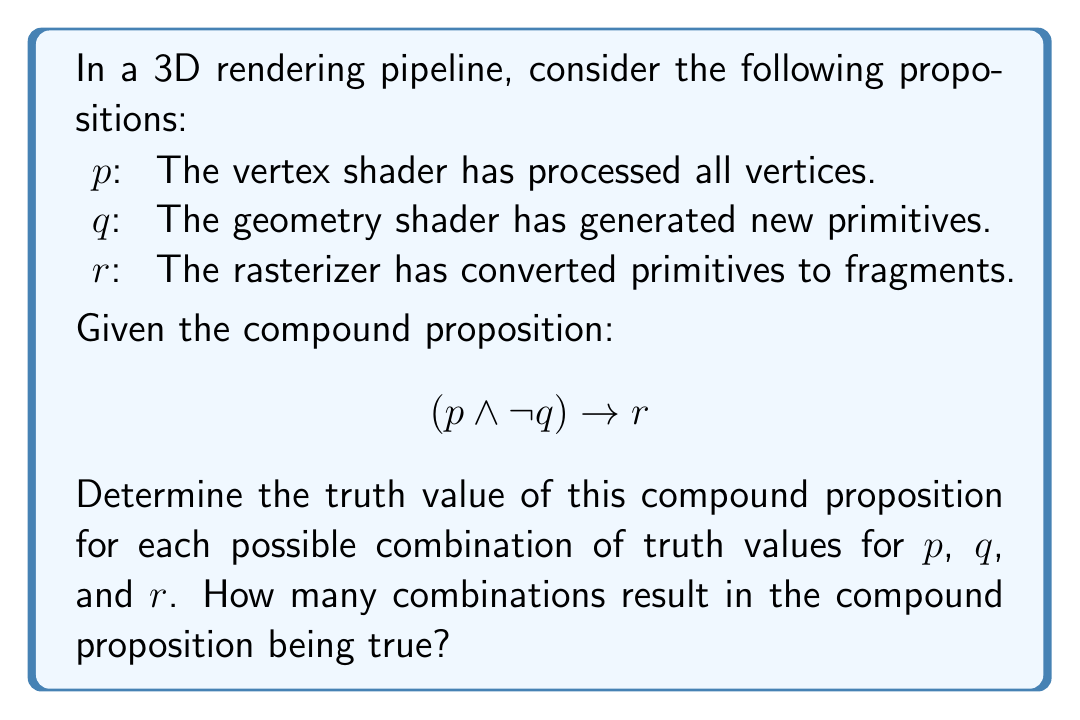Could you help me with this problem? To solve this problem, we need to evaluate the truth value of the compound proposition for all possible combinations of p, q, and r. Let's break it down step by step:

1. First, let's create a truth table for all possible combinations of p, q, and r:

   | p | q | r |
   |---|---|---|
   | T | T | T |
   | T | T | F |
   | T | F | T |
   | T | F | F |
   | F | T | T |
   | F | T | F |
   | F | F | T |
   | F | F | F |

2. Now, let's evaluate $(p \land \neg q)$ for each row:

   | p | q | $\neg q$ | $(p \land \neg q)$ |
   |---|---|----------|---------------------|
   | T | T |    F     |         F           |
   | T | T |    F     |         F           |
   | T | F |    T     |         T           |
   | T | F |    T     |         T           |
   | F | T |    F     |         F           |
   | F | T |    F     |         F           |
   | F | F |    T     |         F           |
   | F | F |    T     |         F           |

3. Finally, let's evaluate the entire compound proposition $(p \land \neg q) \rightarrow r$:

   | p | q | r | $(p \land \neg q)$ | $(p \land \neg q) \rightarrow r$ |
   |---|---|---|---------------------|----------------------------------|
   | T | T | T |         F           |               T                  |
   | T | T | F |         F           |               T                  |
   | T | F | T |         T           |               T                  |
   | T | F | F |         T           |               F                  |
   | F | T | T |         F           |               T                  |
   | F | T | F |         F           |               T                  |
   | F | F | T |         F           |               T                  |
   | F | F | F |         F           |               T                  |

4. Count the number of true values in the last column:

   There are 7 true values in the last column.

Therefore, out of the 8 possible combinations of truth values for p, q, and r, the compound proposition $(p \land \neg q) \rightarrow r$ is true for 7 combinations.
Answer: 7 combinations result in the compound proposition being true. 